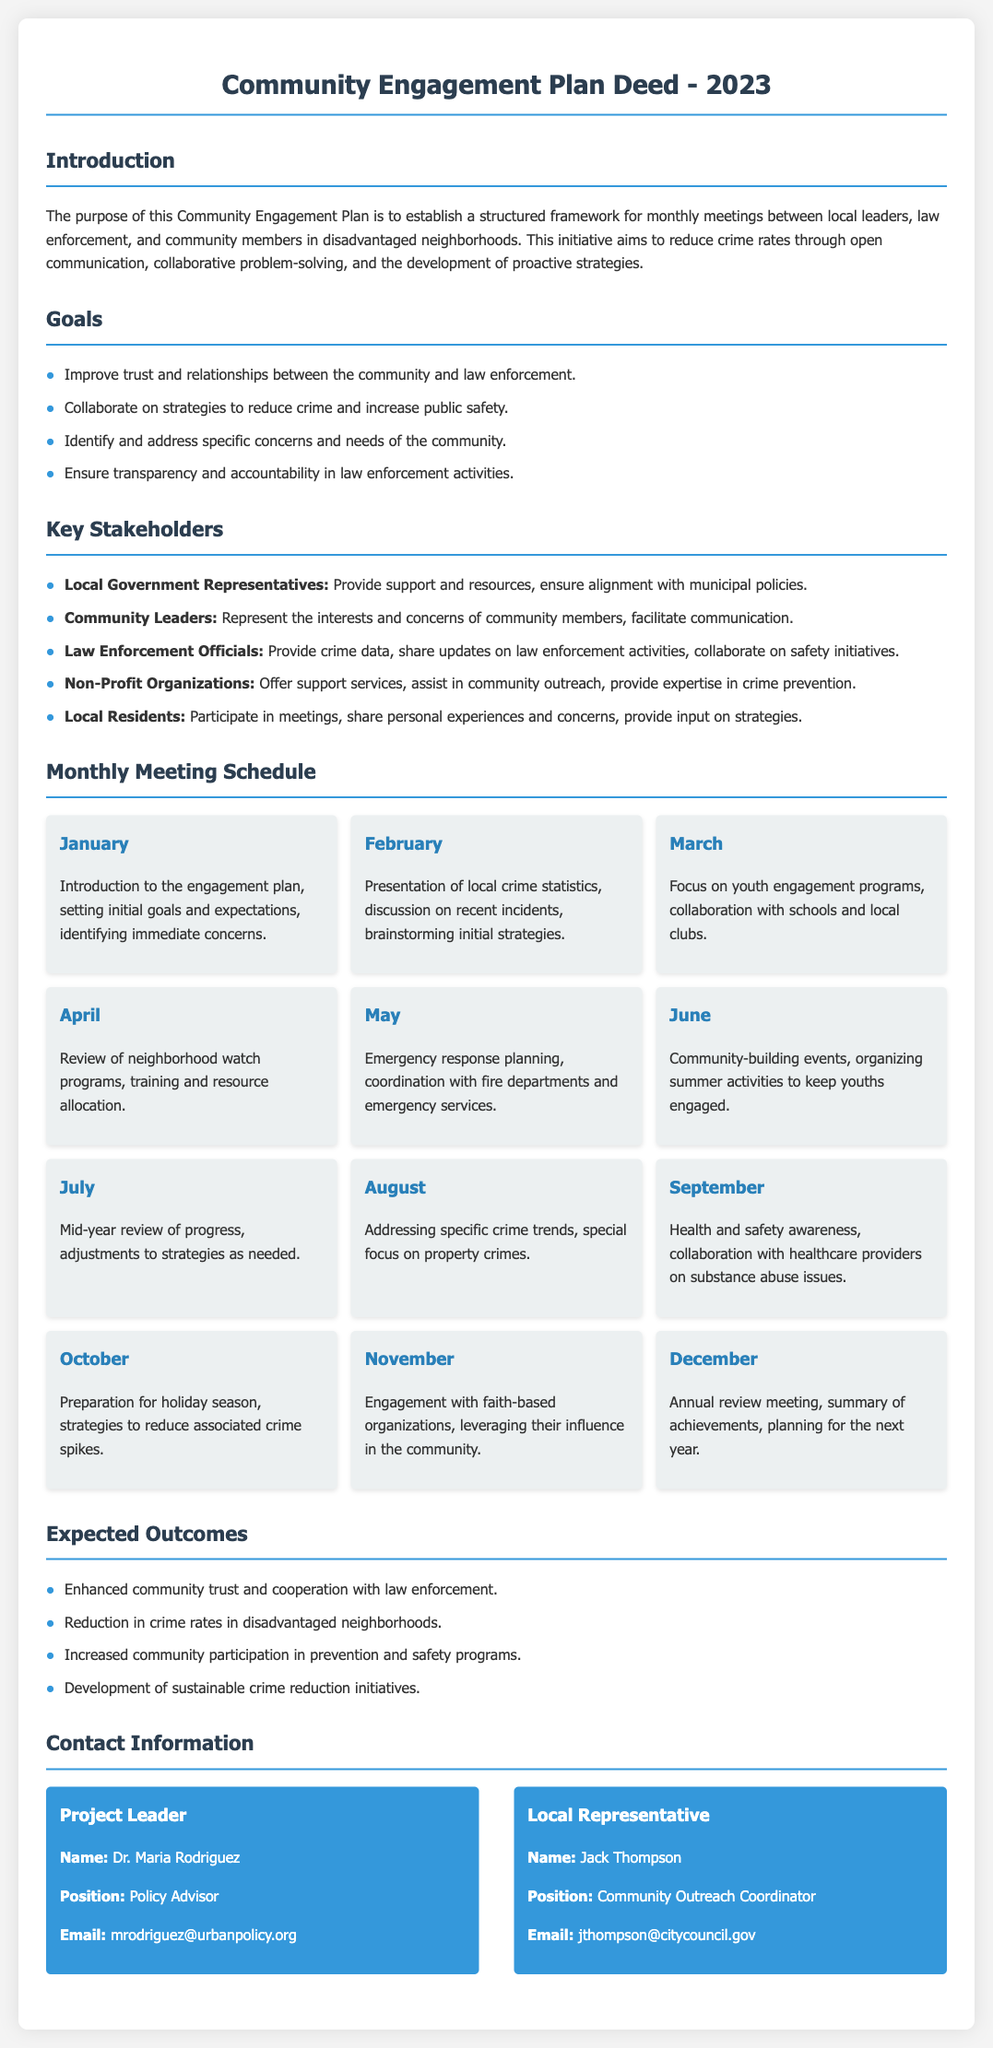What is the primary purpose of the Community Engagement Plan? The Community Engagement Plan aims to establish a structured framework for monthly meetings to reduce crime rates through open communication.
Answer: Reduce crime rates through open communication Who is the Project Leader? The Project Leader is mentioned in the contact information section of the document.
Answer: Dr. Maria Rodriguez In which month will there be a mid-year review of progress? The month for the mid-year review is noted in the monthly meeting schedule.
Answer: July What is one goal of the Community Engagement Plan? Goals are listed in the goals section; any of them could be a valid answer.
Answer: Improve trust and relationships between the community and law enforcement How many months are covered in the meeting schedule? The monthly meeting schedule outlines meetings for each month of the year.
Answer: Twelve Which stakeholders are responsible for providing crime data? The key stakeholders section specifies the roles of different groups.
Answer: Law Enforcement Officials What event is scheduled for December? December's activities are described in the monthly meeting schedule.
Answer: Annual review meeting What type of organizations will engage with community leaders in November? The document specifies the type of organizations involved in the November meeting.
Answer: Faith-based organizations 